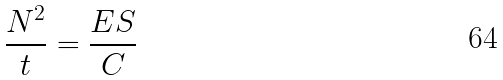<formula> <loc_0><loc_0><loc_500><loc_500>\frac { N ^ { 2 } } { t } = \frac { E S } { C }</formula> 